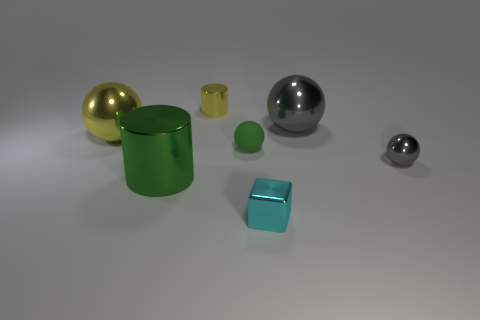Subtract 2 balls. How many balls are left? 2 Add 3 big gray things. How many objects exist? 10 Subtract all cylinders. How many objects are left? 5 Add 7 tiny cyan blocks. How many tiny cyan blocks exist? 8 Subtract 2 gray spheres. How many objects are left? 5 Subtract all yellow shiny objects. Subtract all large gray metal balls. How many objects are left? 4 Add 7 yellow shiny objects. How many yellow shiny objects are left? 9 